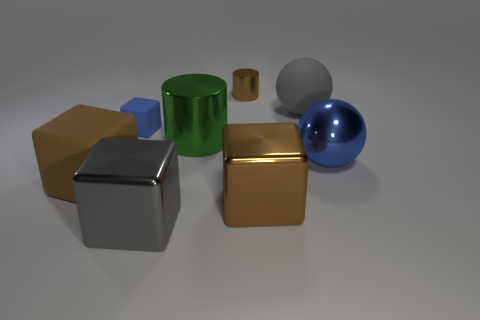Subtract all big gray cubes. How many cubes are left? 3 Add 2 blue metallic balls. How many objects exist? 10 Subtract all blue blocks. How many blocks are left? 3 Subtract 1 blocks. How many blocks are left? 3 Subtract all yellow blocks. Subtract all green cylinders. How many blocks are left? 4 Subtract all cylinders. How many objects are left? 6 Add 2 brown matte things. How many brown matte things are left? 3 Add 7 small gray metal cubes. How many small gray metal cubes exist? 7 Subtract 0 yellow balls. How many objects are left? 8 Subtract all tiny brown cylinders. Subtract all big yellow spheres. How many objects are left? 7 